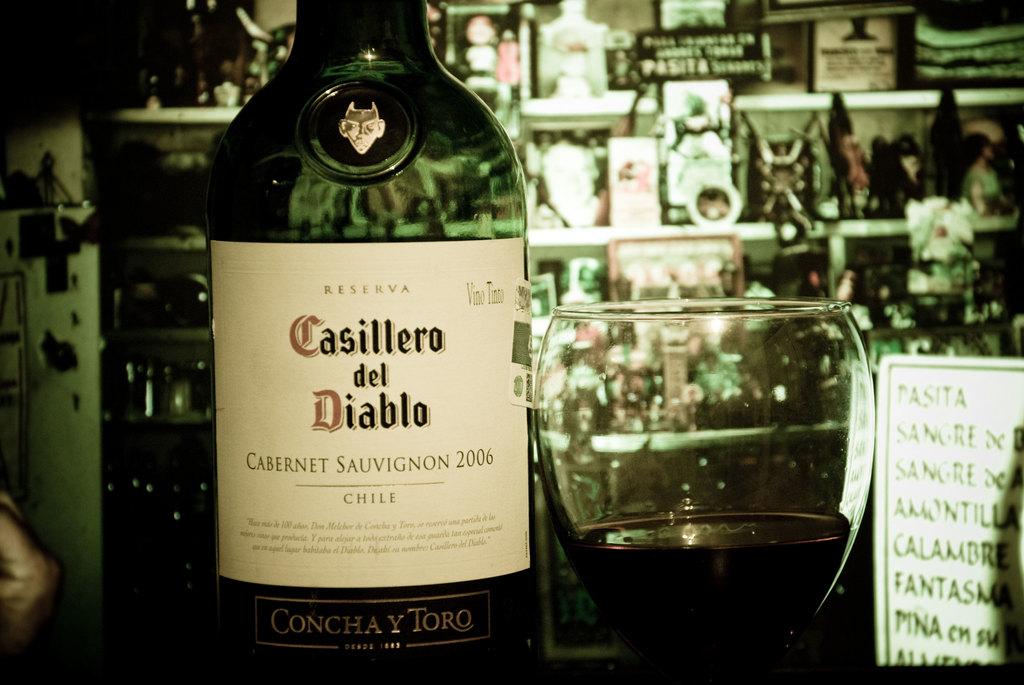What language is the wine label in?
Your response must be concise. Spanish. What is the name of this wine?
Your response must be concise. Casillero del diablo. 